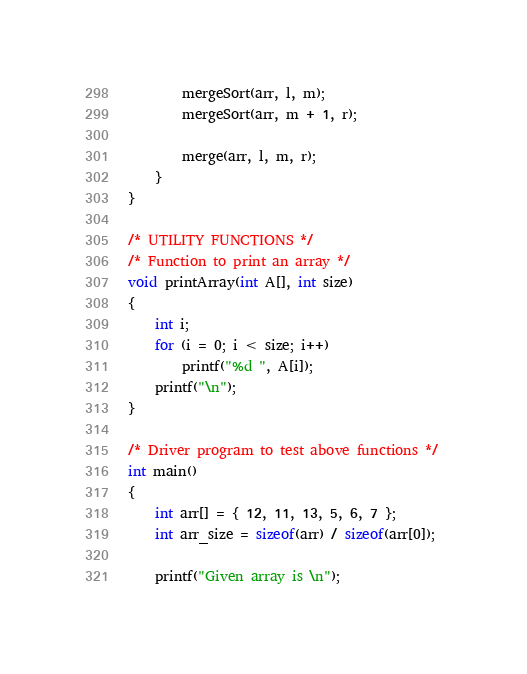Convert code to text. <code><loc_0><loc_0><loc_500><loc_500><_C_>        mergeSort(arr, l, m); 
        mergeSort(arr, m + 1, r); 
  
        merge(arr, l, m, r); 
    } 
} 
  
/* UTILITY FUNCTIONS */
/* Function to print an array */
void printArray(int A[], int size) 
{ 
    int i; 
    for (i = 0; i < size; i++) 
        printf("%d ", A[i]); 
    printf("\n"); 
} 
  
/* Driver program to test above functions */
int main() 
{ 
    int arr[] = { 12, 11, 13, 5, 6, 7 }; 
    int arr_size = sizeof(arr) / sizeof(arr[0]); 
  
    printf("Given array is \n"); </code> 